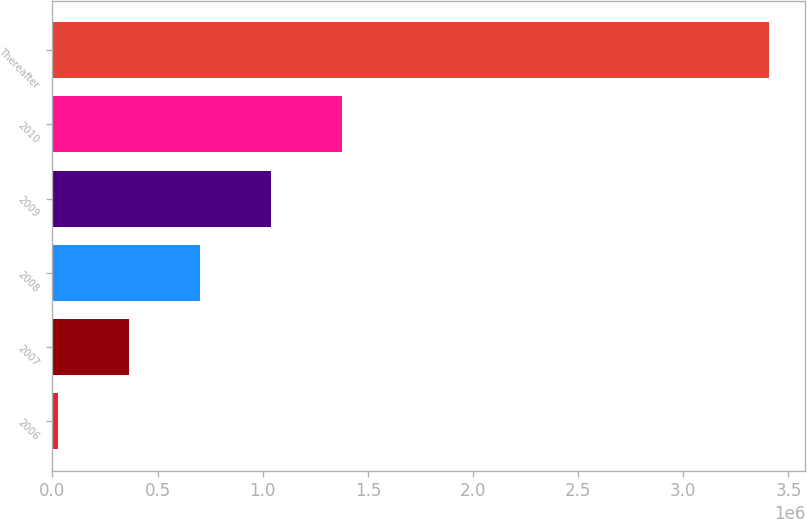Convert chart to OTSL. <chart><loc_0><loc_0><loc_500><loc_500><bar_chart><fcel>2006<fcel>2007<fcel>2008<fcel>2009<fcel>2010<fcel>Thereafter<nl><fcel>26656<fcel>364854<fcel>703051<fcel>1.04125e+06<fcel>1.37945e+06<fcel>3.40863e+06<nl></chart> 